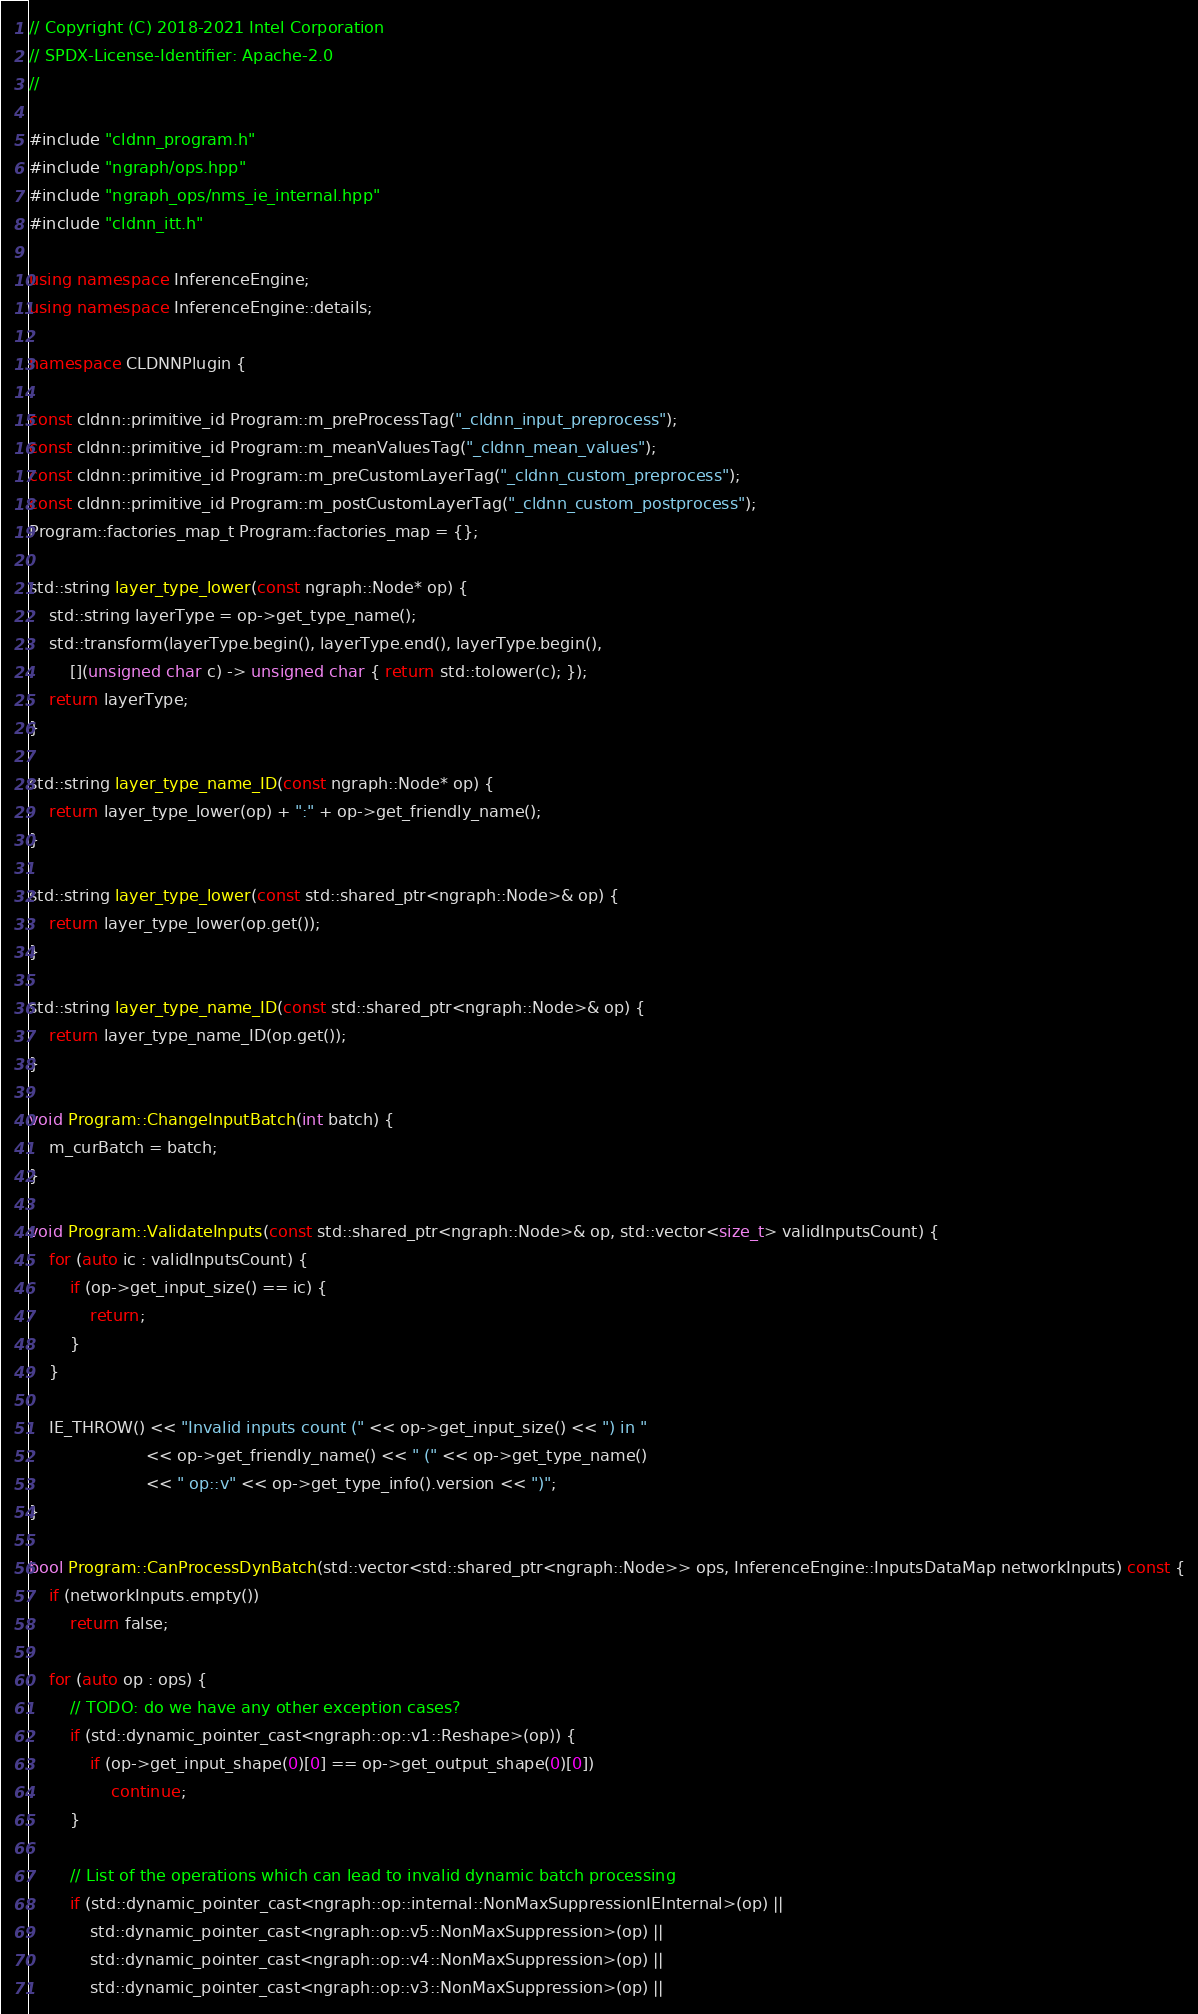<code> <loc_0><loc_0><loc_500><loc_500><_C++_>// Copyright (C) 2018-2021 Intel Corporation
// SPDX-License-Identifier: Apache-2.0
//

#include "cldnn_program.h"
#include "ngraph/ops.hpp"
#include "ngraph_ops/nms_ie_internal.hpp"
#include "cldnn_itt.h"

using namespace InferenceEngine;
using namespace InferenceEngine::details;

namespace CLDNNPlugin {

const cldnn::primitive_id Program::m_preProcessTag("_cldnn_input_preprocess");
const cldnn::primitive_id Program::m_meanValuesTag("_cldnn_mean_values");
const cldnn::primitive_id Program::m_preCustomLayerTag("_cldnn_custom_preprocess");
const cldnn::primitive_id Program::m_postCustomLayerTag("_cldnn_custom_postprocess");
Program::factories_map_t Program::factories_map = {};

std::string layer_type_lower(const ngraph::Node* op) {
    std::string layerType = op->get_type_name();
    std::transform(layerType.begin(), layerType.end(), layerType.begin(),
        [](unsigned char c) -> unsigned char { return std::tolower(c); });
    return layerType;
}

std::string layer_type_name_ID(const ngraph::Node* op) {
    return layer_type_lower(op) + ":" + op->get_friendly_name();
}

std::string layer_type_lower(const std::shared_ptr<ngraph::Node>& op) {
    return layer_type_lower(op.get());
}

std::string layer_type_name_ID(const std::shared_ptr<ngraph::Node>& op) {
    return layer_type_name_ID(op.get());
}

void Program::ChangeInputBatch(int batch) {
    m_curBatch = batch;
}

void Program::ValidateInputs(const std::shared_ptr<ngraph::Node>& op, std::vector<size_t> validInputsCount) {
    for (auto ic : validInputsCount) {
        if (op->get_input_size() == ic) {
            return;
        }
    }

    IE_THROW() << "Invalid inputs count (" << op->get_input_size() << ") in "
                       << op->get_friendly_name() << " (" << op->get_type_name()
                       << " op::v" << op->get_type_info().version << ")";
}

bool Program::CanProcessDynBatch(std::vector<std::shared_ptr<ngraph::Node>> ops, InferenceEngine::InputsDataMap networkInputs) const {
    if (networkInputs.empty())
        return false;

    for (auto op : ops) {
        // TODO: do we have any other exception cases?
        if (std::dynamic_pointer_cast<ngraph::op::v1::Reshape>(op)) {
            if (op->get_input_shape(0)[0] == op->get_output_shape(0)[0])
                continue;
        }

        // List of the operations which can lead to invalid dynamic batch processing
        if (std::dynamic_pointer_cast<ngraph::op::internal::NonMaxSuppressionIEInternal>(op) ||
            std::dynamic_pointer_cast<ngraph::op::v5::NonMaxSuppression>(op) ||
            std::dynamic_pointer_cast<ngraph::op::v4::NonMaxSuppression>(op) ||
            std::dynamic_pointer_cast<ngraph::op::v3::NonMaxSuppression>(op) ||</code> 